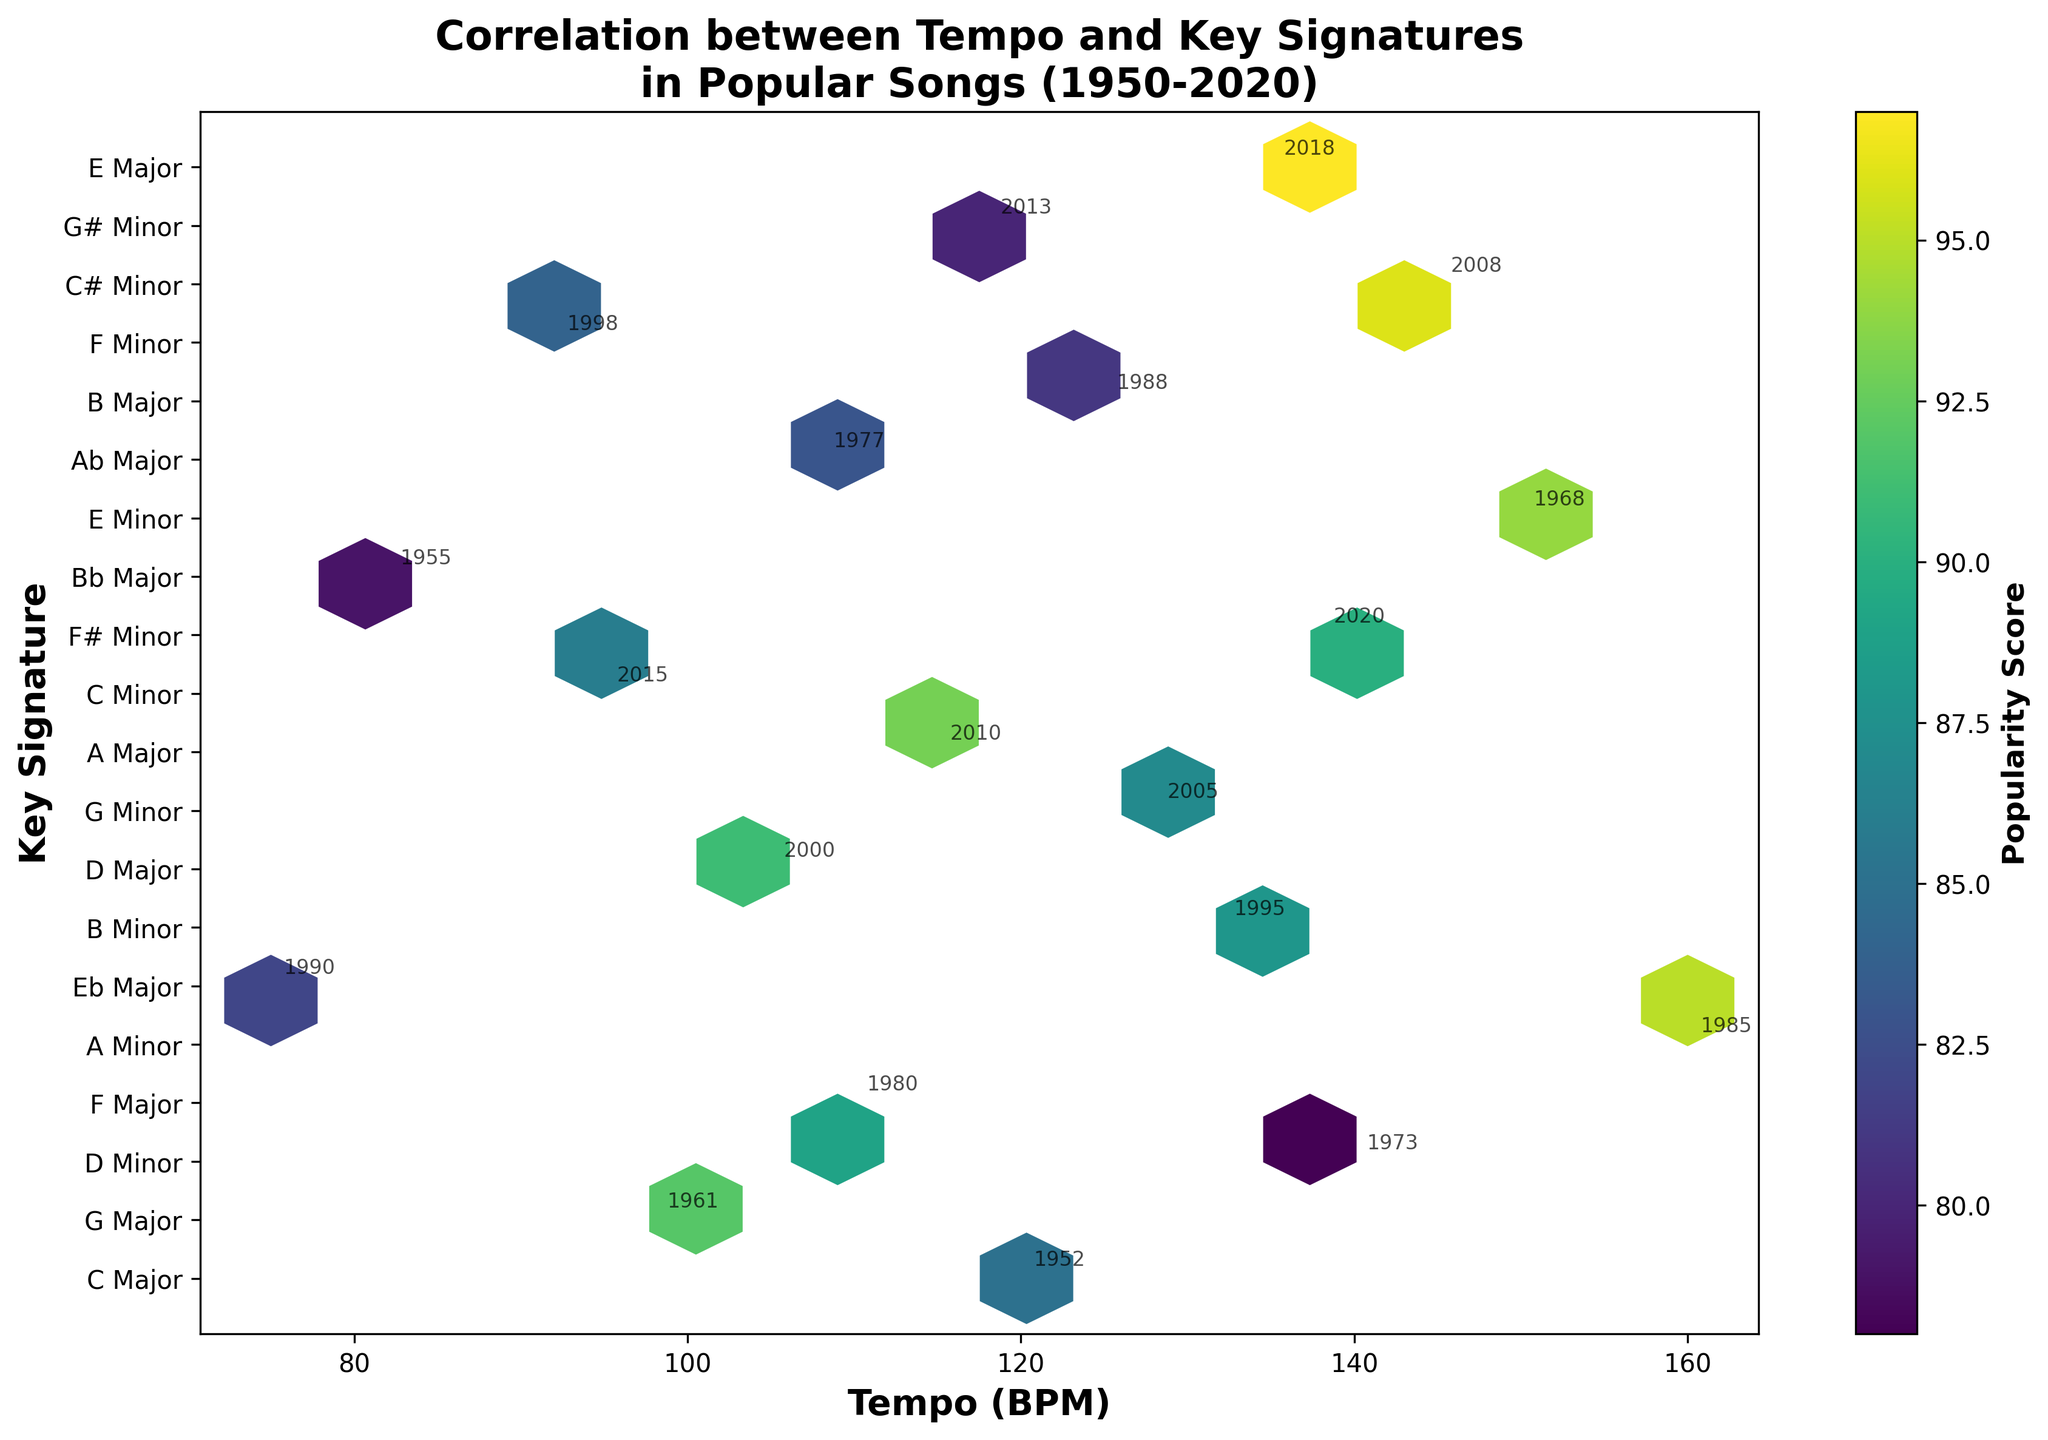What is the title of the figure? The title of the figure is prominently displayed at the top of the plot. It provides an overview of what the plot represents.
Answer: Correlation between Tempo and Key Signatures in Popular Songs (1950-2020) How many key signatures are represented in the figure? The y-axis labels correspond to different key signatures. By counting these labels, we can determine the number of unique key signatures.
Answer: 12 What does the color of the hexagons represent? The color of the hexagons is explained by the color bar on the right side of the plot. It indicates that different colors correspond to varying "Popularity Scores".
Answer: Popularity Score Which key signature shows a high concentration of songs with a tempo around 120 BPM? By observing the density of hexagons around the 120 BPM mark, we can identify which key signature has a higher concentration of songs in that tempo range. Based on the y-axis labels, we can find the corresponding key signature.
Answer: C Major Which tempo ranges have the highest popularity scores in the A Minor key signature? To find this, we need to look at the hexagons along the A Minor key signature (mapped on the y-axis) and identify the ones with darker (higher popularity score) colors.
Answer: 160 BPM Which year had a popular song with approximately 150 BPM in the E Minor key signature? The plot includes annotations with years. By locating the hexagon with these characteristics and reading the nearby year label, we can determine the year.
Answer: 1968 Can you compare the popularity score of songs in F Major with a tempo of 110 BPM and G Major with a tempo of 98 BPM? Look at the specific hexagons for these key signatures and tempo values. The color intensity of the hexagons will give an idea of the popularity score. F Major with 110 BPM is around 89, while G Major with 98 BPM is around 92.
Answer: G Major (92) > F Major (89) What is the trend of tempos from 1950 to 2020 in the data? By observing the position of annotated years on the plot, sorted by tempo, we can deduce if there’s an increasing, decreasing, or stable trend over time.
Answer: There's no clear linear trend; tempos vary over the period Which key signature has the most diverse range of tempos? The key signature with hexagons spread across the widest tempo range on the x-axis indicates the most diversity in tempo.
Answer: E Minor What can be said about the popularity of songs in minor key signatures compared to major key signatures? By examining the hexagons' colors (popularity scores), we can compare the popularity levels of songs in minor (darker color) vs major key signatures.
Answer: Minor key signatures tend to have higher popularity scores 